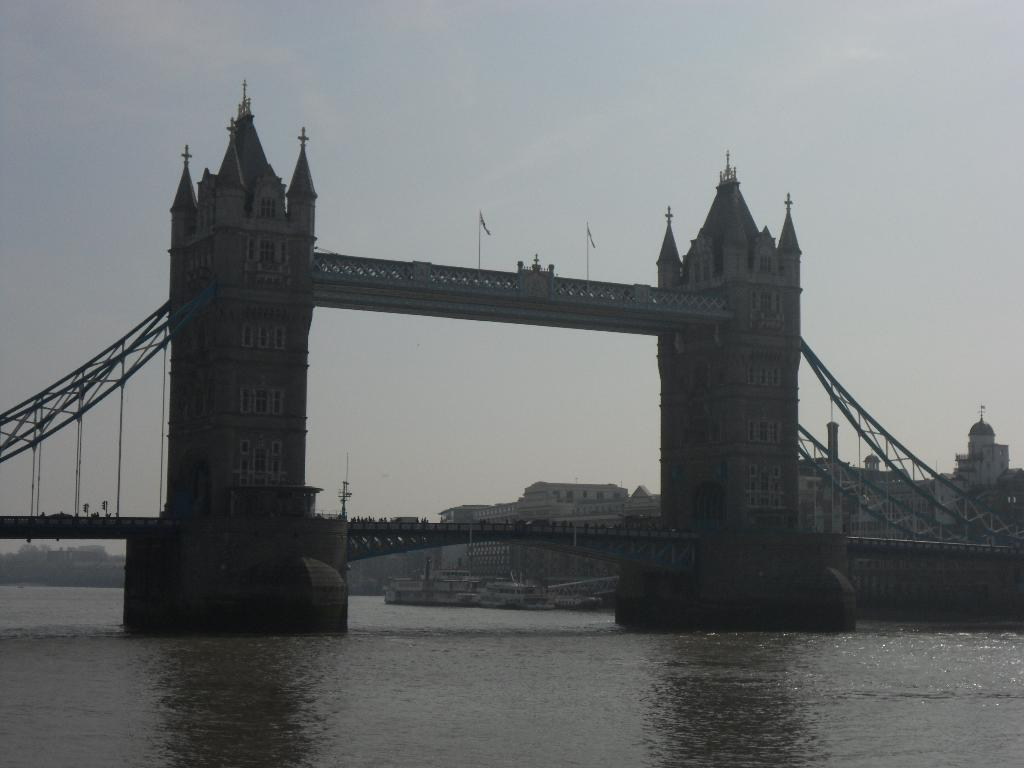What is the main structure in the center of the image? There is a tower bridge in the center of the image. What is located at the bottom side of the image? There is water at the bottom side of the image. What can be seen in the background of the image? There are buildings in the background area of the image. What type of creature can be seen swimming in the water in the image? There are no creatures visible in the image; it only features a tower bridge, water, and buildings. 